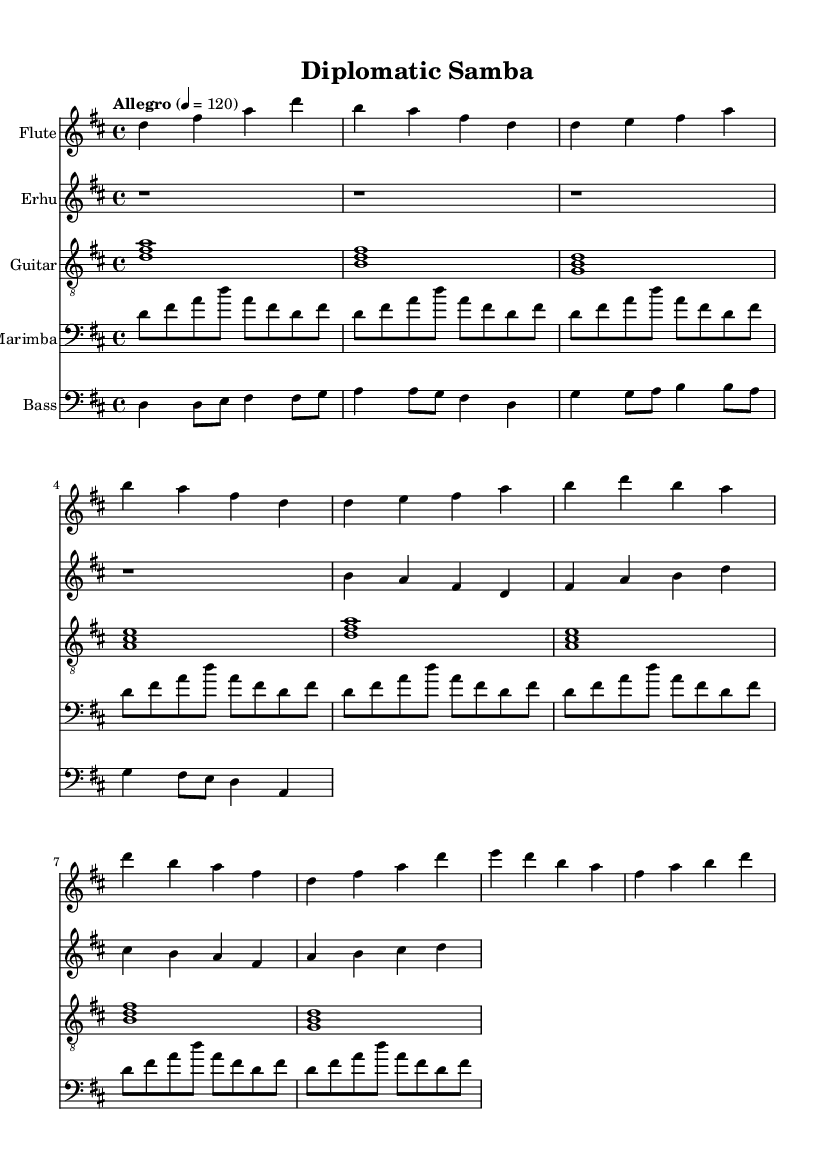What is the key signature of this music? The key signature in the provided music is in D major, which has two sharps (F# and C#). This can be determined by looking at the beginning of each staff where the sharps are indicated.
Answer: D major What is the time signature of this piece? The time signature shown in the sheet music is 4/4, which means there are four beats in each measure and the quarter note gets one beat. This can be identified right after the key signature at the beginning of the score.
Answer: 4/4 What is the tempo marking for this piece? The tempo marking at the beginning of the score indicates "Allegro," which means it is to be played quickly and lively. The specific metronome marking of 120 beats per minute is also included, further defining the speed.
Answer: Allegro How many instruments are included in this score? The score consists of five instruments: flute, erhu, guitar, marimba, and bass. Each one is represented in a separate staff, which can be counted from the score layout.
Answer: Five Which instrument has the melody in the chorus section? In the chorus section, the flute carries the main melody, supported by harmonies from the erhu and accompaniment from the guitar. The melody is dictated by looking at the flute part during the chorus measures.
Answer: Flute What type of musical elements are used in the bass part? The bass part features a walking bass line with Latin-inspired syncopation. This can be seen in the rhythm and note choices that create a distinct Latin feel present in the bass part.
Answer: Walking bass with syncopation Which feature characterizes the marimba part in this piece? The marimba part is characterized by an ostinato pattern that repeats throughout the piece, creating a rhythmic foundation. This can be observed by the repeated short rhythmic phrases in the marimba section.
Answer: Ostinato pattern 